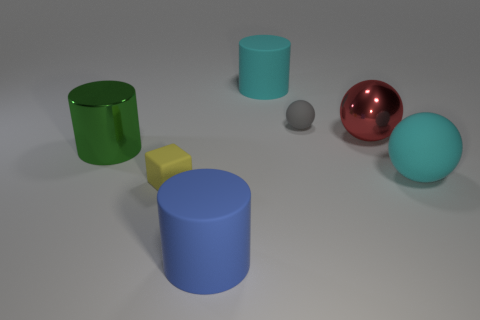What materials might these objects be made of, assuming they exist in the real world? Judging by their appearances, the green and blue cylinders could be made of colored plastic or painted metal due to their opaque surfaces. The red sphere seems to have a reflective metallic finish, suggesting it might be made of polished metal. The cyan matte sphere and the small grey sphere look like they might be made from a matte plastic or perhaps even ceramic, given their non-reflective surfaces. Lastly, the yellow cube might also be a plastic or wooden object, indicated by its solid and opaque appearance. 